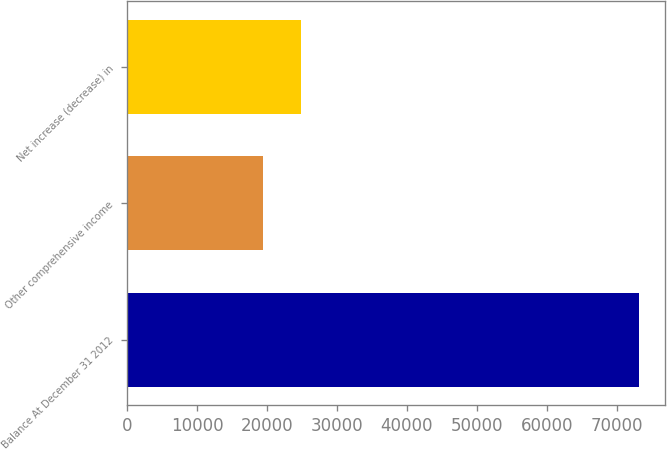<chart> <loc_0><loc_0><loc_500><loc_500><bar_chart><fcel>Balance At December 31 2012<fcel>Other comprehensive income<fcel>Net increase (decrease) in<nl><fcel>73182<fcel>19478<fcel>24848.4<nl></chart> 